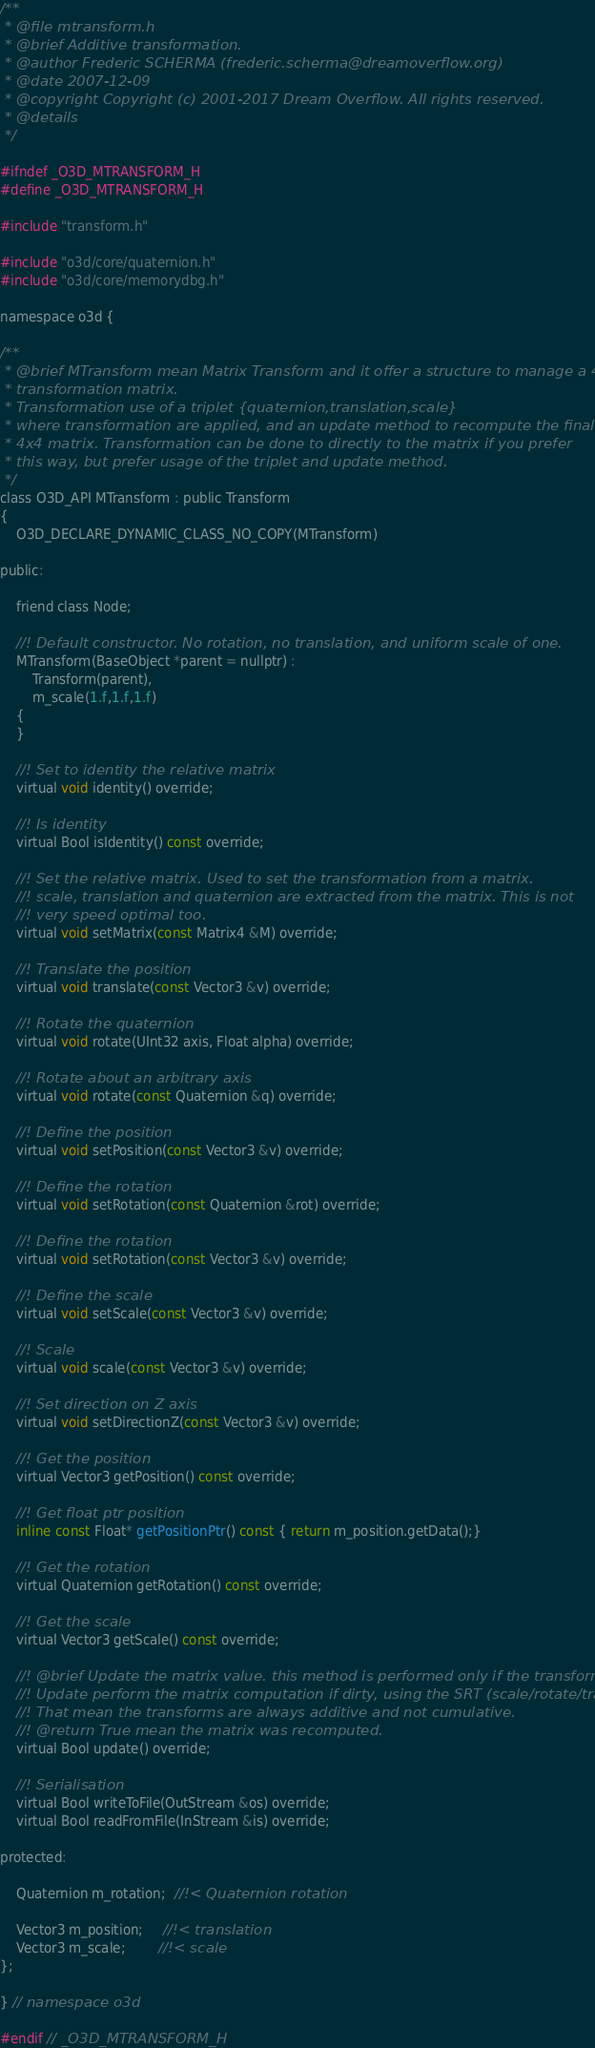<code> <loc_0><loc_0><loc_500><loc_500><_C_>/**
 * @file mtransform.h
 * @brief Additive transformation.
 * @author Frederic SCHERMA (frederic.scherma@dreamoverflow.org)
 * @date 2007-12-09
 * @copyright Copyright (c) 2001-2017 Dream Overflow. All rights reserved.
 * @details 
 */

#ifndef _O3D_MTRANSFORM_H
#define _O3D_MTRANSFORM_H

#include "transform.h"

#include "o3d/core/quaternion.h"
#include "o3d/core/memorydbg.h"

namespace o3d {

/**
 * @brief MTransform mean Matrix Transform and it offer a structure to manage a 4x4
 * transformation matrix.
 * Transformation use of a triplet {quaternion,translation,scale}
 * where transformation are applied, and an update method to recompute the final
 * 4x4 matrix. Transformation can be done to directly to the matrix if you prefer
 * this way, but prefer usage of the triplet and update method.
 */
class O3D_API MTransform : public Transform
{
	O3D_DECLARE_DYNAMIC_CLASS_NO_COPY(MTransform)

public:

	friend class Node;

	//! Default constructor. No rotation, no translation, and uniform scale of one.
    MTransform(BaseObject *parent = nullptr) :
		Transform(parent),
		m_scale(1.f,1.f,1.f)
    {
    }

	//! Set to identity the relative matrix
    virtual void identity() override;

	//! Is identity
    virtual Bool isIdentity() const override;

	//! Set the relative matrix. Used to set the transformation from a matrix.
	//! scale, translation and quaternion are extracted from the matrix. This is not
	//! very speed optimal too.
    virtual void setMatrix(const Matrix4 &M) override;

	//! Translate the position
    virtual void translate(const Vector3 &v) override;

	//! Rotate the quaternion
    virtual void rotate(UInt32 axis, Float alpha) override;

	//! Rotate about an arbitrary axis
    virtual void rotate(const Quaternion &q) override;

	//! Define the position
    virtual void setPosition(const Vector3 &v) override;

	//! Define the rotation
    virtual void setRotation(const Quaternion &rot) override;

	//! Define the rotation
    virtual void setRotation(const Vector3 &v) override;

	//! Define the scale
    virtual void setScale(const Vector3 &v) override;

	//! Scale
    virtual void scale(const Vector3 &v) override;

	//! Set direction on Z axis
    virtual void setDirectionZ(const Vector3 &v) override;

	//! Get the position
    virtual Vector3 getPosition() const override;

	//! Get float ptr position
	inline const Float* getPositionPtr() const { return m_position.getData();}

	//! Get the rotation
    virtual Quaternion getRotation() const override;

	//! Get the scale
    virtual Vector3 getScale() const override;

	//! @brief Update the matrix value. this method is performed only if the transform is dirty.
	//! Update perform the matrix computation if dirty, using the SRT (scale/rotate/translate).
	//! That mean the transforms are always additive and not cumulative.
	//! @return True mean the matrix was recomputed.
    virtual Bool update() override;

	//! Serialisation
    virtual Bool writeToFile(OutStream &os) override;
    virtual Bool readFromFile(InStream &is) override;

protected:

	Quaternion m_rotation;  //!< Quaternion rotation

	Vector3 m_position;     //!< translation
	Vector3 m_scale;        //!< scale
};

} // namespace o3d

#endif // _O3D_MTRANSFORM_H
</code> 